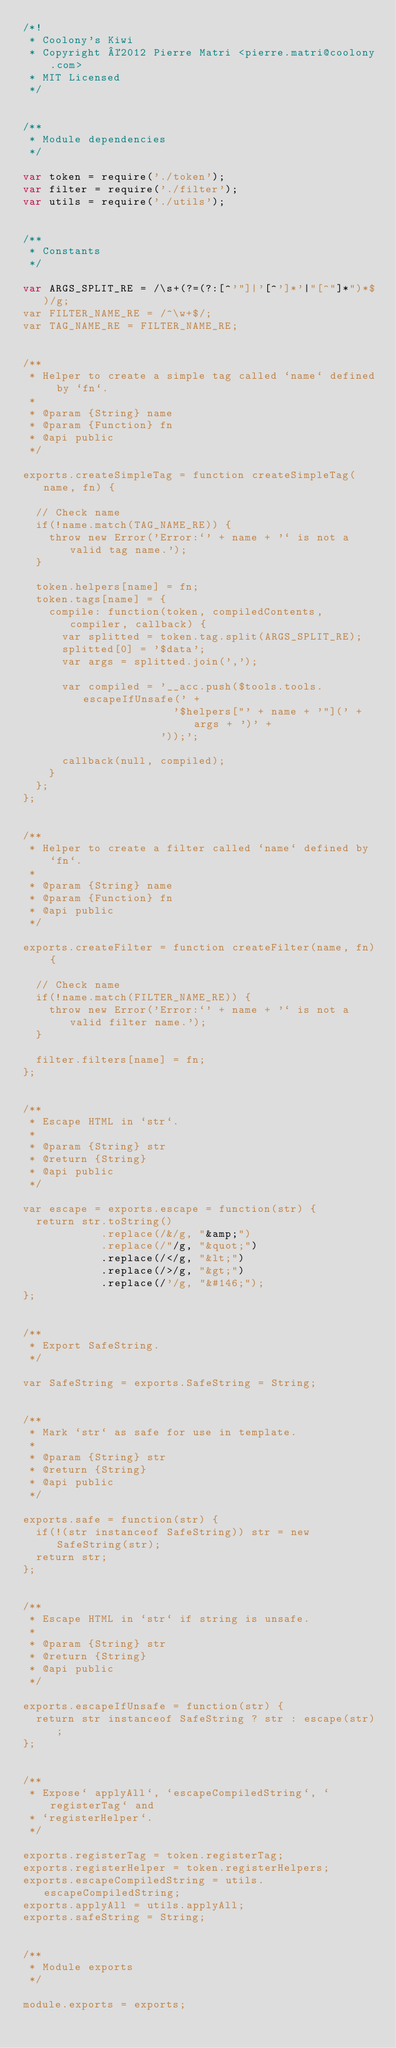<code> <loc_0><loc_0><loc_500><loc_500><_JavaScript_>/*!
 * Coolony's Kiwi
 * Copyright ©2012 Pierre Matri <pierre.matri@coolony.com>
 * MIT Licensed
 */


/**
 * Module dependencies
 */

var token = require('./token');
var filter = require('./filter');
var utils = require('./utils');


/**
 * Constants
 */

var ARGS_SPLIT_RE = /\s+(?=(?:[^'"]|'[^']*'|"[^"]*")*$)/g;
var FILTER_NAME_RE = /^\w+$/;
var TAG_NAME_RE = FILTER_NAME_RE;


/**
 * Helper to create a simple tag called `name` defined by `fn`.
 *
 * @param {String} name
 * @param {Function} fn
 * @api public
 */

exports.createSimpleTag = function createSimpleTag(name, fn) {

  // Check name
  if(!name.match(TAG_NAME_RE)) {
    throw new Error('Error:`' + name + '` is not a valid tag name.');
  }

  token.helpers[name] = fn;
  token.tags[name] = {
    compile: function(token, compiledContents, compiler, callback) {
      var splitted = token.tag.split(ARGS_SPLIT_RE);
      splitted[0] = '$data';
      var args = splitted.join(',');

      var compiled = '__acc.push($tools.tools.escapeIfUnsafe(' +
                       '$helpers["' + name + '"](' + args + ')' +
                     '));';

      callback(null, compiled);
    }
  };
};


/**
 * Helper to create a filter called `name` defined by `fn`.
 *
 * @param {String} name
 * @param {Function} fn
 * @api public
 */

exports.createFilter = function createFilter(name, fn) {

  // Check name
  if(!name.match(FILTER_NAME_RE)) {
    throw new Error('Error:`' + name + '` is not a valid filter name.');
  }

  filter.filters[name] = fn;
};


/**
 * Escape HTML in `str`.
 *
 * @param {String} str
 * @return {String}
 * @api public
 */

var escape = exports.escape = function(str) {
  return str.toString()
            .replace(/&/g, "&amp;")
            .replace(/"/g, "&quot;")
            .replace(/</g, "&lt;")
            .replace(/>/g, "&gt;")
            .replace(/'/g, "&#146;");
};


/**
 * Export SafeString.
 */

var SafeString = exports.SafeString = String;


/**
 * Mark `str` as safe for use in template.
 *
 * @param {String} str
 * @return {String}
 * @api public
 */

exports.safe = function(str) {
  if(!(str instanceof SafeString)) str = new SafeString(str);
  return str;
};


/**
 * Escape HTML in `str` if string is unsafe.
 *
 * @param {String} str
 * @return {String}
 * @api public
 */

exports.escapeIfUnsafe = function(str) {
  return str instanceof SafeString ? str : escape(str);
};


/**
 * Expose` applyAll`, `escapeCompiledString`, `registerTag` and
 * `registerHelper`.
 */

exports.registerTag = token.registerTag;
exports.registerHelper = token.registerHelpers;
exports.escapeCompiledString = utils.escapeCompiledString;
exports.applyAll = utils.applyAll;
exports.safeString = String;


/**
 * Module exports
 */

module.exports = exports;</code> 